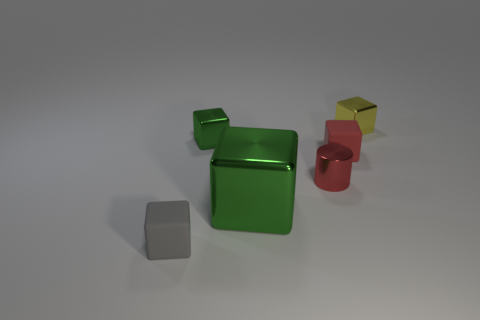Are the objects in the image solid or hollow? The objects in the image give the impression of being solid due to their uniform surfaces and lack of visible openings. 